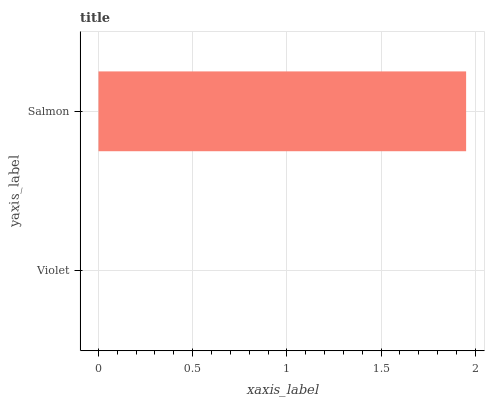Is Violet the minimum?
Answer yes or no. Yes. Is Salmon the maximum?
Answer yes or no. Yes. Is Salmon the minimum?
Answer yes or no. No. Is Salmon greater than Violet?
Answer yes or no. Yes. Is Violet less than Salmon?
Answer yes or no. Yes. Is Violet greater than Salmon?
Answer yes or no. No. Is Salmon less than Violet?
Answer yes or no. No. Is Salmon the high median?
Answer yes or no. Yes. Is Violet the low median?
Answer yes or no. Yes. Is Violet the high median?
Answer yes or no. No. Is Salmon the low median?
Answer yes or no. No. 